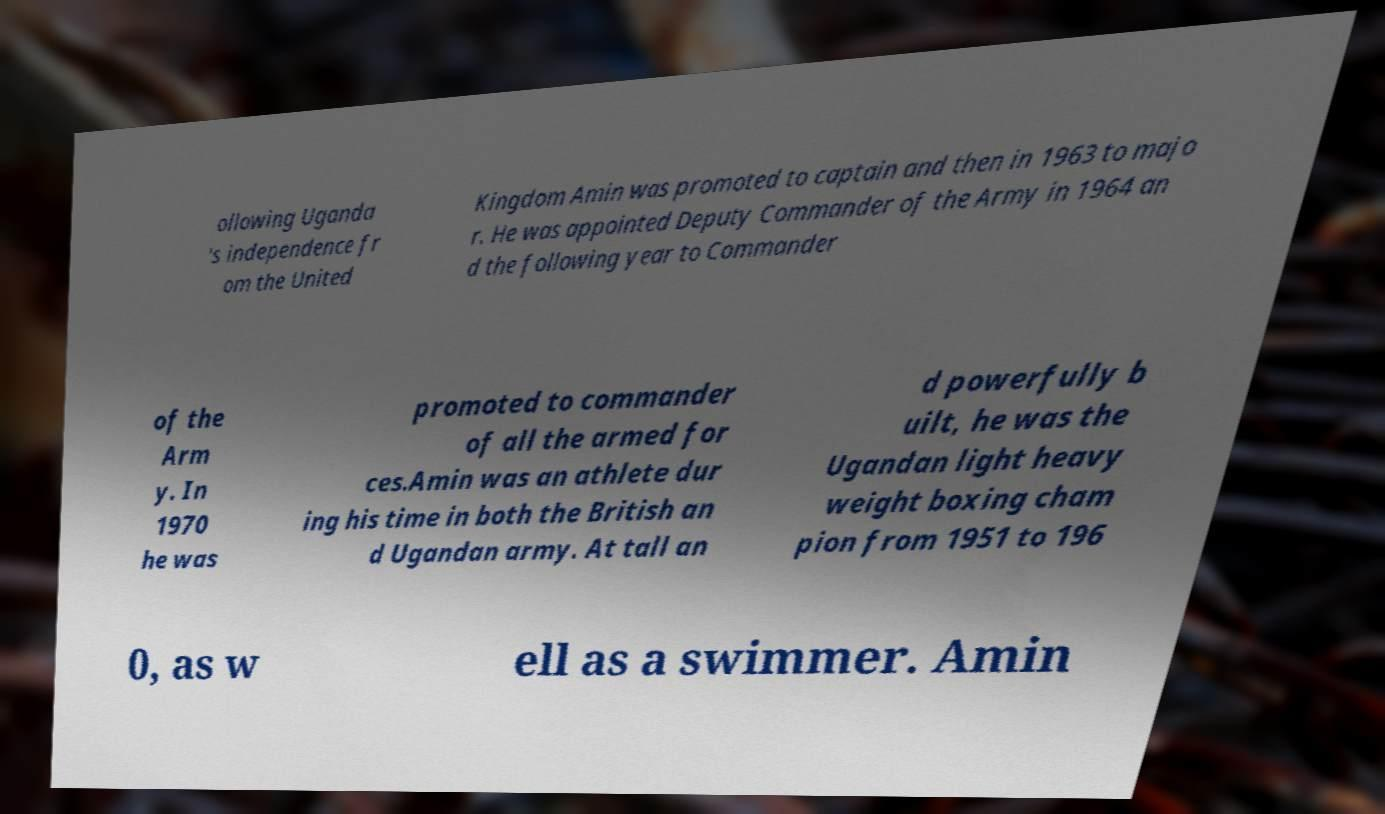Could you extract and type out the text from this image? ollowing Uganda 's independence fr om the United Kingdom Amin was promoted to captain and then in 1963 to majo r. He was appointed Deputy Commander of the Army in 1964 an d the following year to Commander of the Arm y. In 1970 he was promoted to commander of all the armed for ces.Amin was an athlete dur ing his time in both the British an d Ugandan army. At tall an d powerfully b uilt, he was the Ugandan light heavy weight boxing cham pion from 1951 to 196 0, as w ell as a swimmer. Amin 